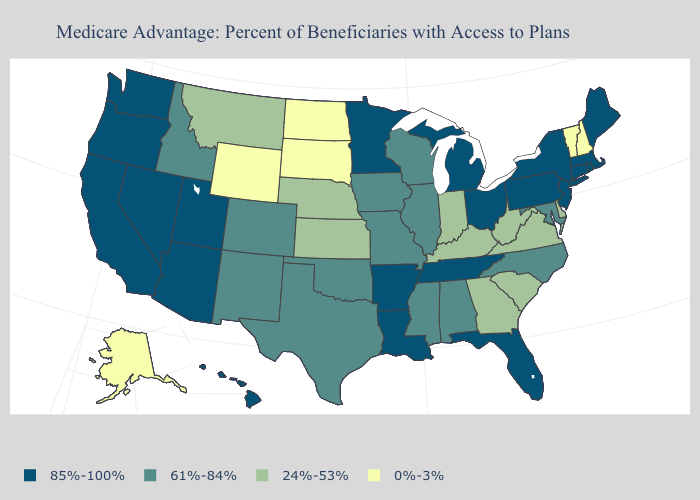What is the value of New Jersey?
Keep it brief. 85%-100%. Name the states that have a value in the range 85%-100%?
Short answer required. Arkansas, Arizona, California, Connecticut, Florida, Hawaii, Louisiana, Massachusetts, Maine, Michigan, Minnesota, New Jersey, Nevada, New York, Ohio, Oregon, Pennsylvania, Rhode Island, Tennessee, Utah, Washington. What is the value of Washington?
Keep it brief. 85%-100%. Does Connecticut have a higher value than Alaska?
Write a very short answer. Yes. Does Pennsylvania have a higher value than South Carolina?
Quick response, please. Yes. What is the value of Connecticut?
Be succinct. 85%-100%. What is the lowest value in the West?
Concise answer only. 0%-3%. Does Mississippi have the lowest value in the South?
Concise answer only. No. Is the legend a continuous bar?
Answer briefly. No. What is the value of Ohio?
Write a very short answer. 85%-100%. What is the value of Utah?
Keep it brief. 85%-100%. Among the states that border New Hampshire , does Vermont have the highest value?
Write a very short answer. No. Does Kentucky have the highest value in the USA?
Quick response, please. No. Which states hav the highest value in the Northeast?
Be succinct. Connecticut, Massachusetts, Maine, New Jersey, New York, Pennsylvania, Rhode Island. 